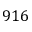<formula> <loc_0><loc_0><loc_500><loc_500>9 1 6</formula> 